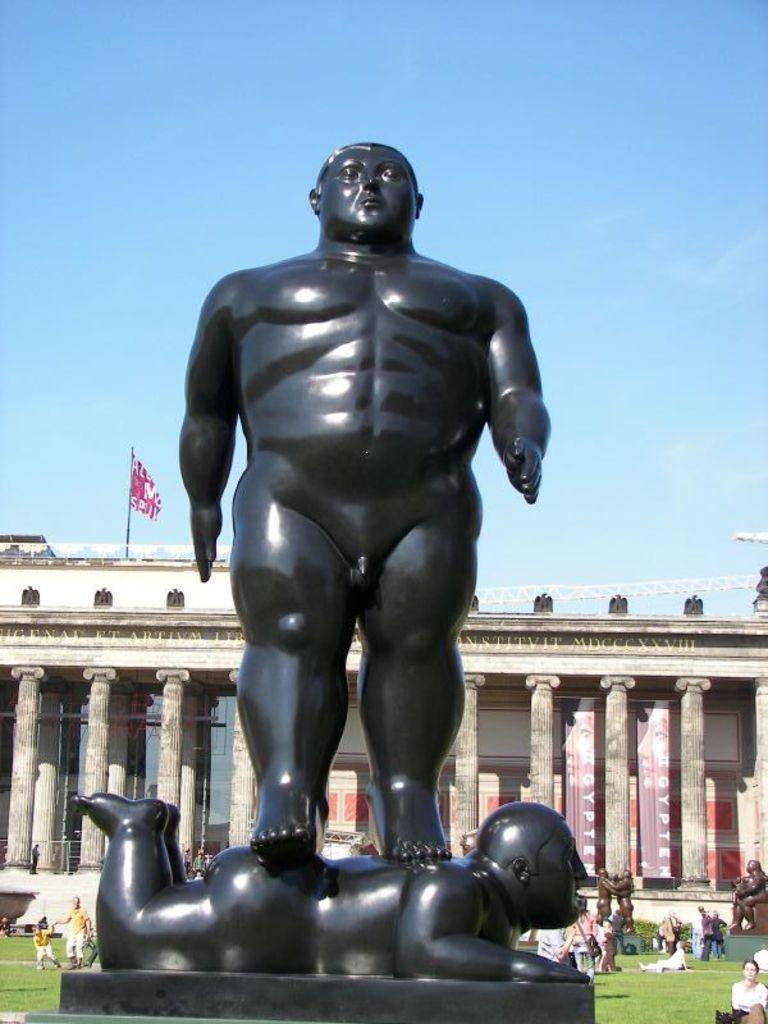Please provide a concise description of this image. In this image I can see a huge statue of two persons which is black in color. I can see the ground, some grass, few persons, few statues and a huge building. I can see few banners and a flag to the building. In the background I can see the sky. 